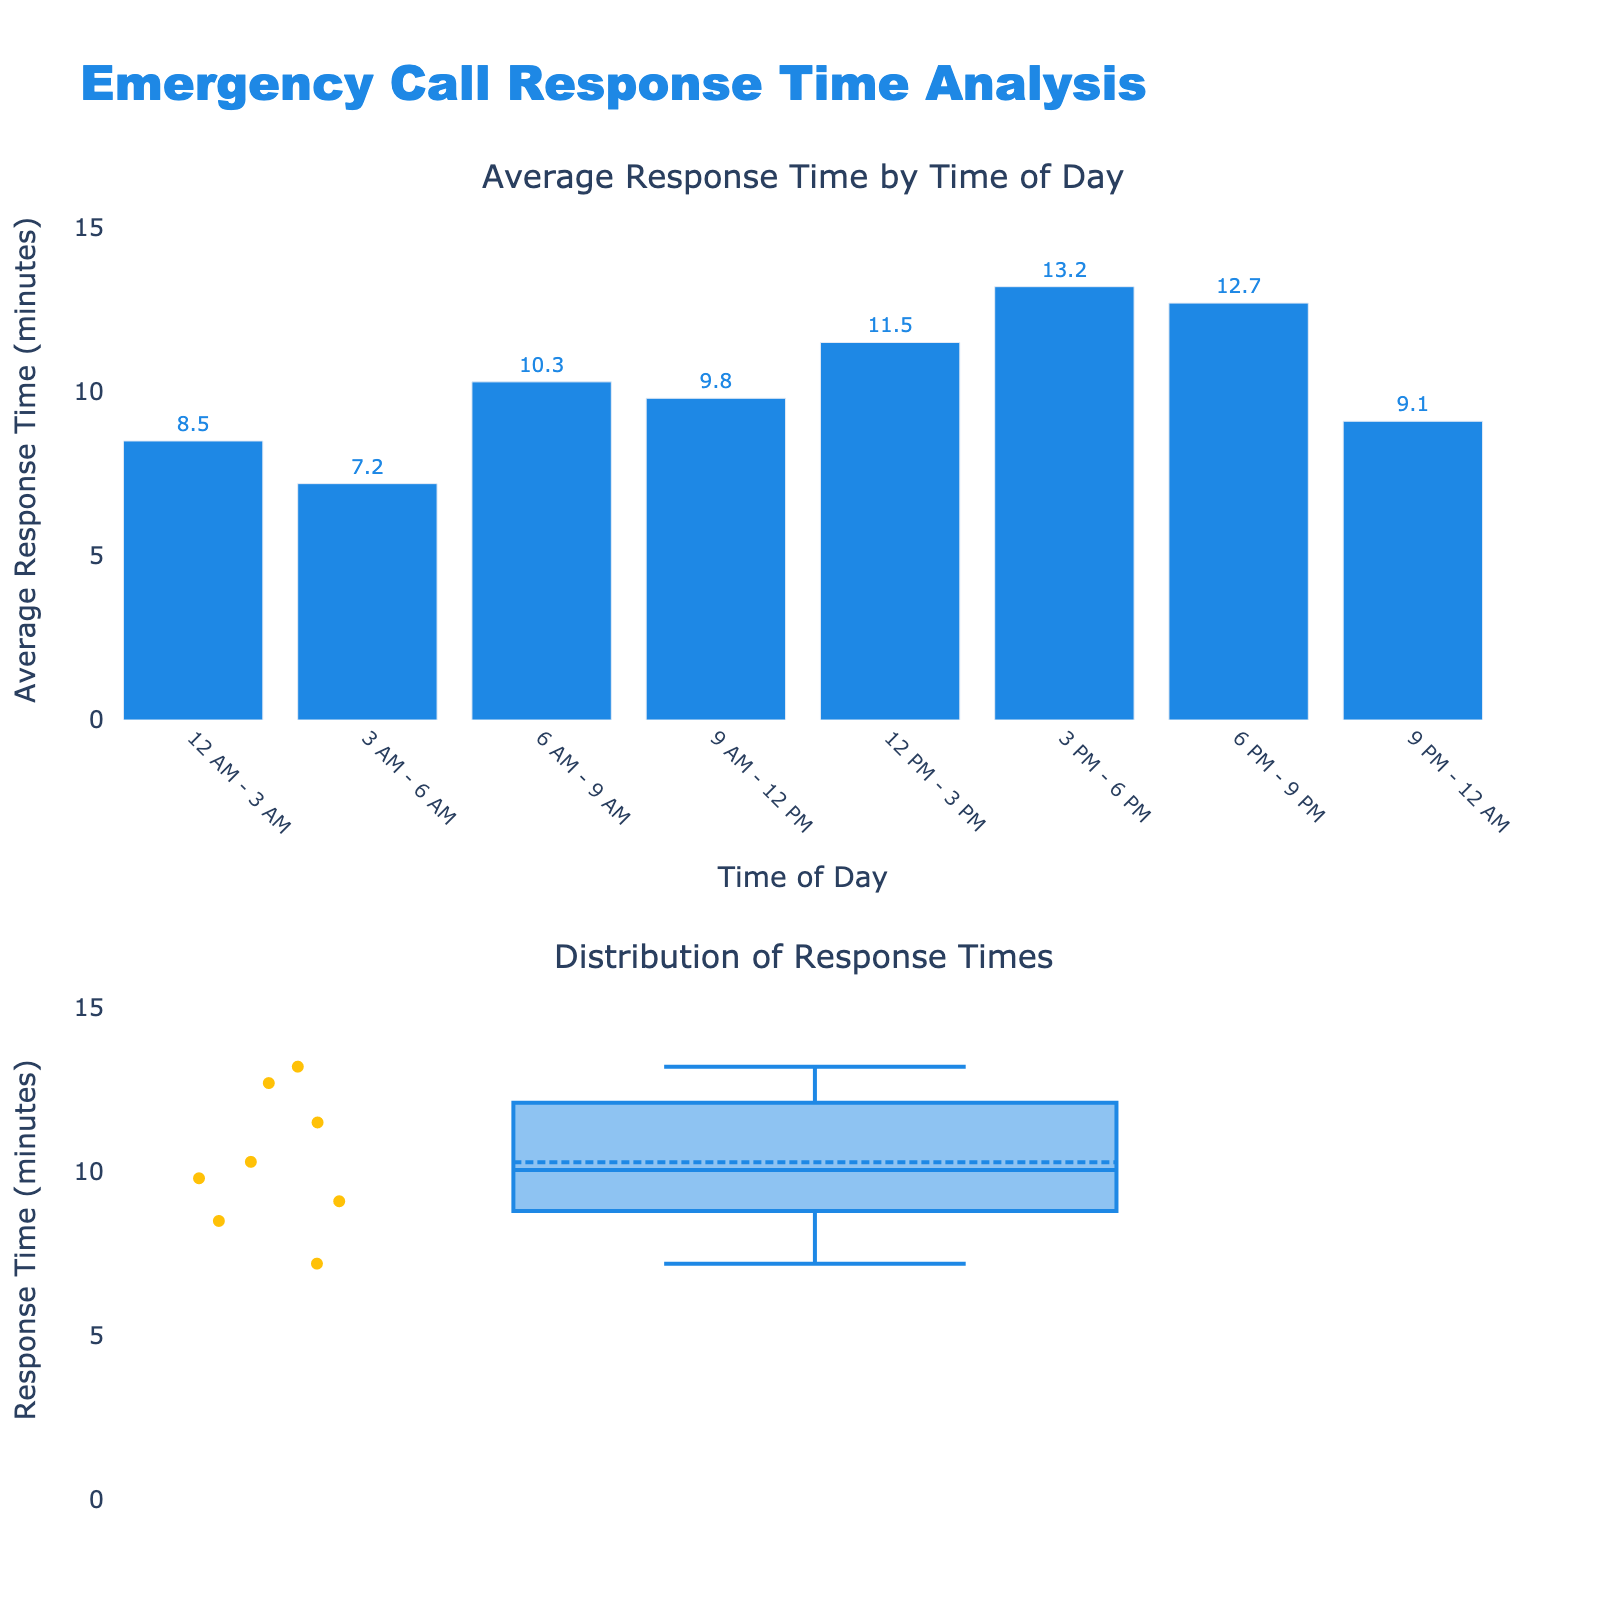What is the title of the chart? The title of the chart is found at the top, and it is "Emergency Call Response Time Analysis".
Answer: Emergency Call Response Time Analysis What is the time interval with the highest average response time? From the bar chart, the highest bar represents the time interval with the highest average response time, which is 3 PM - 6 PM with an average response time of 13.2 minutes.
Answer: 3 PM - 6 PM How much higher is the response time at 3 PM - 6 PM compared to 3 AM - 6 AM? We subtract the average response time at 3 AM - 6 AM from that at 3 PM - 6 PM: 13.2 - 7.2 = 6.0 minutes.
Answer: 6.0 minutes Which time interval has the lowest average response time and what is it? The shortest bar in the first plot indicates the time with the lowest average response time, which is 3 AM - 6 AM with an average response time of 7.2 minutes.
Answer: 3 AM - 6 AM, 7.2 minutes What are the colors used in the bar chart and the box plot? The bar chart uses blue bars with the average response time indicated in blue text, while the box plot uses yellow for points, blue for the box edges, and blue for the mean line.
Answer: Blue (bars and text), Yellow (points), Blue (box edges and mean line) Are there any outliers in the response time distribution? In the box plot, outliers are indicated by points that lie outside the whiskers of the plot. There are several points (outliers) scattered above and below the main box.
Answer: Yes What can you infer about the variability in response times? The box plot shows a wide range of response times with multiple outliers, indicating significant variability and some extreme values.
Answer: High variability Is there a significant difference in response time between daytime and nighttime? Daytime (6 AM - 6 PM) has higher average response times (10.3, 9.8, 11.5, 13.2 minutes) compared to nighttime (6 PM - 6 AM) with generally lower times (12.7, 9.1, 8.5, 7.2 minutes).
Answer: Yes What is the general trend in response times from early morning to late night? The average response times gradually increase from early morning (7.2 minutes) to late afternoon (13.2 minutes) and then decrease again towards late night (9.1 minutes).
Answer: Increase, then decrease What is the variability of response times at different times of the day as shown by the box plot? Variability is indicated by the spread of points in the box plot. The response times range widely with some extreme outliers, suggesting fluctuating response times throughout the day.
Answer: High variability with outliers 